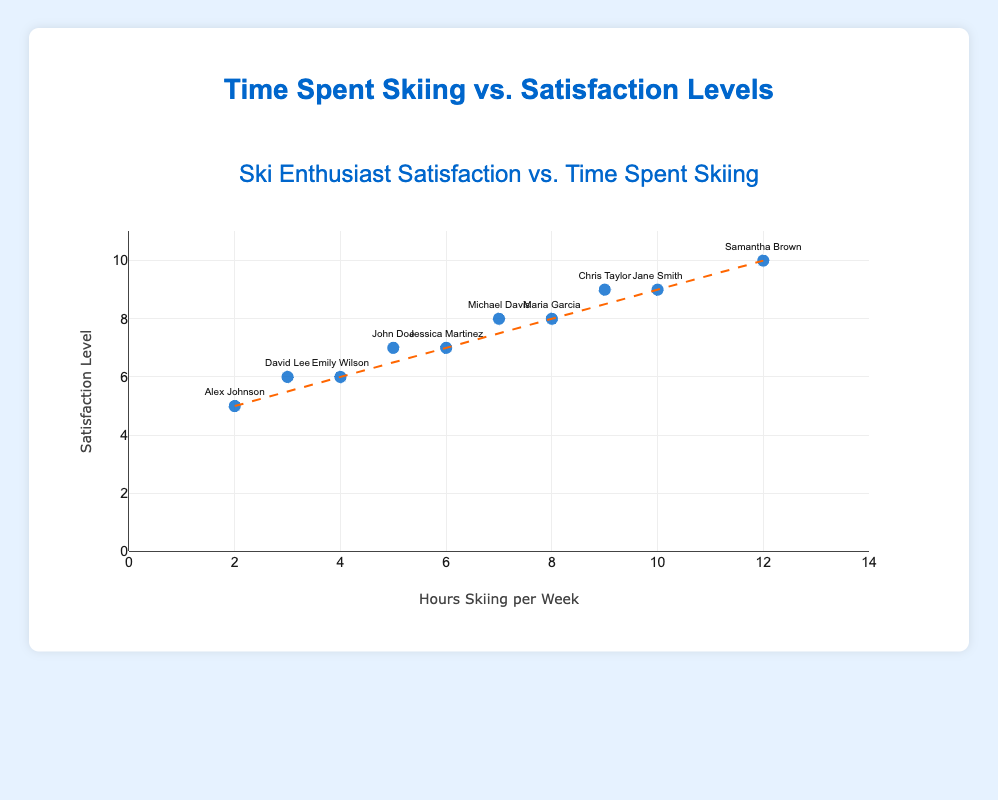What's the title of the plot? The title of the plot is located at the top and it reads "Ski Enthusiast Satisfaction vs. Time Spent Skiing."
Answer: Ski Enthusiast Satisfaction vs. Time Spent Skiing What are the axis labels for the plot? The x-axis is labeled "Hours Skiing per Week," and the y-axis is labeled "Satisfaction Level."
Answer: Hours Skiing per Week, Satisfaction Level What is the range of hours spent skiing per week on the x-axis? The x-axis shows a range from 0 to 14 hours.
Answer: 0 to 14 How many data points are on the plot? By counting the markers, there are 10 data points on the plot, each representing an individual amateur skier.
Answer: 10 Which amateur skier reported the highest satisfaction level? Hovering over the markers shows the names and values; Samantha Brown spent 12 hours skiing per week and reported the highest satisfaction of 10.
Answer: Samantha Brown What is the average satisfaction level of the skiers? Calculate the sum of the satisfaction levels (7 + 9 + 5 + 8 + 6 + 10 + 8 + 6 + 9 + 7 = 75) and divide by the number of data points (10). The average satisfaction level is 75/10 = 7.5.
Answer: 7.5 Which skier spends the fewest hours skiing per week and what is their satisfaction level? Alex Johnson spends the fewest hours skiing per week (2 hours) and has a satisfaction level of 5.
Answer: Alex Johnson, 5 Is there a positive correlation between hours spent skiing and satisfaction levels? The trend line on the plot slopes upward from the bottom left to the top right, indicating a positive correlation: as hours skiing per week increase, so do satisfaction levels.
Answer: Yes Who spends the same amount of time skiing but has different satisfaction levels? John Doe and Jessica Martinez both spend 6 hours skiing per week, but their satisfaction levels are 7 and 7, respectively.
Answer: John Doe and Jessica Martinez What is the satisfaction level of the skier who spends an average 6 hours skiing per week? Referring to the data points for 6 hours, Jessica Martinez has a satisfaction level of 7 and John Doe spends 5 hours with a satisfaction level of 7.
Answer: 7 